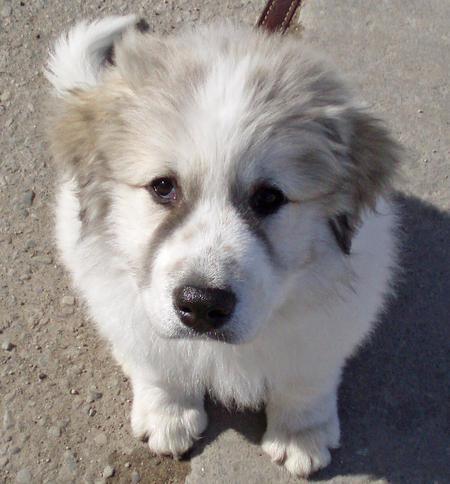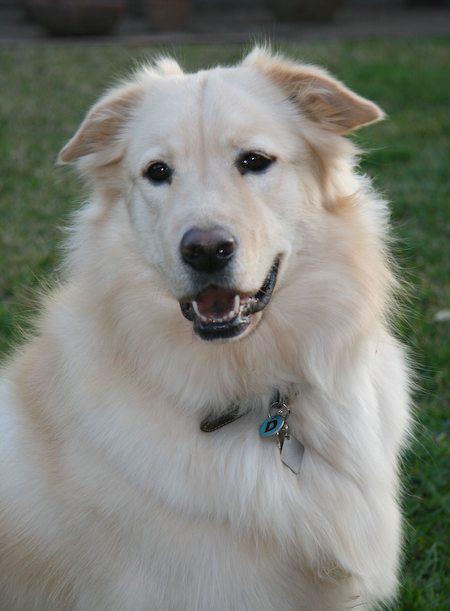The first image is the image on the left, the second image is the image on the right. Analyze the images presented: Is the assertion "The left image shows a white dog in the grass." valid? Answer yes or no. No. 